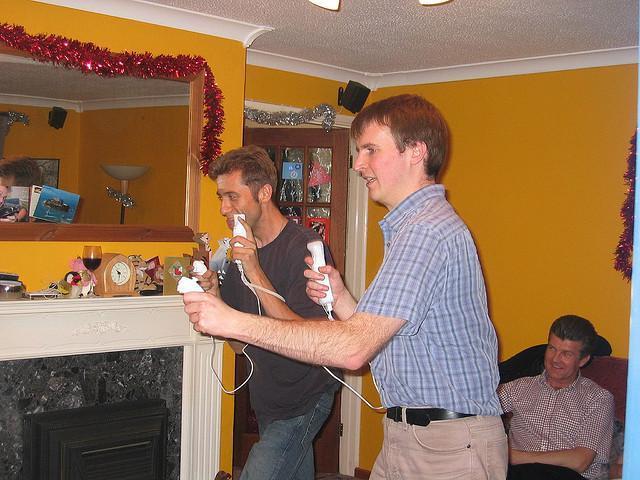How many people are visible?
Give a very brief answer. 3. 